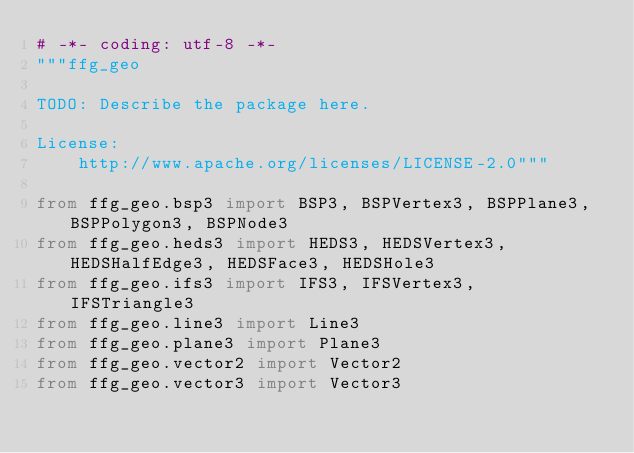<code> <loc_0><loc_0><loc_500><loc_500><_Python_># -*- coding: utf-8 -*-
"""ffg_geo

TODO: Describe the package here.

License:
    http://www.apache.org/licenses/LICENSE-2.0"""

from ffg_geo.bsp3 import BSP3, BSPVertex3, BSPPlane3, BSPPolygon3, BSPNode3
from ffg_geo.heds3 import HEDS3, HEDSVertex3, HEDSHalfEdge3, HEDSFace3, HEDSHole3
from ffg_geo.ifs3 import IFS3, IFSVertex3, IFSTriangle3
from ffg_geo.line3 import Line3
from ffg_geo.plane3 import Plane3
from ffg_geo.vector2 import Vector2
from ffg_geo.vector3 import Vector3
</code> 